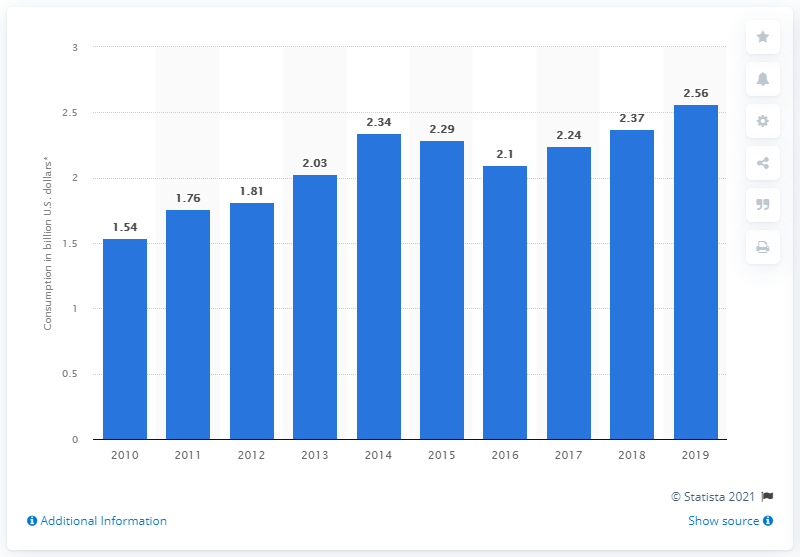Point out several critical features in this image. In 2014, internal tourism consumption in El Salvador decreased by two years. 